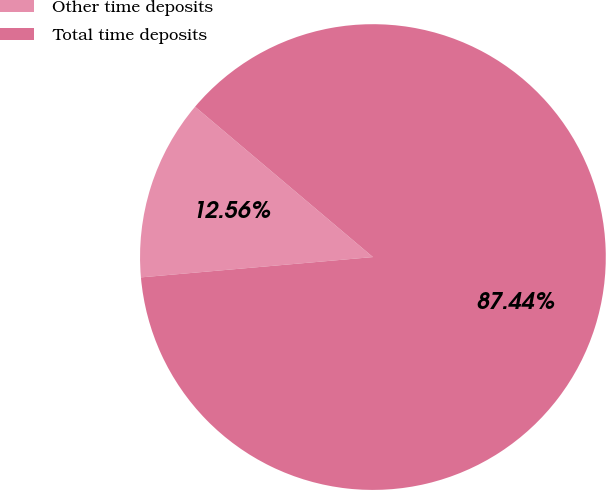Convert chart. <chart><loc_0><loc_0><loc_500><loc_500><pie_chart><fcel>Other time deposits<fcel>Total time deposits<nl><fcel>12.56%<fcel>87.44%<nl></chart> 